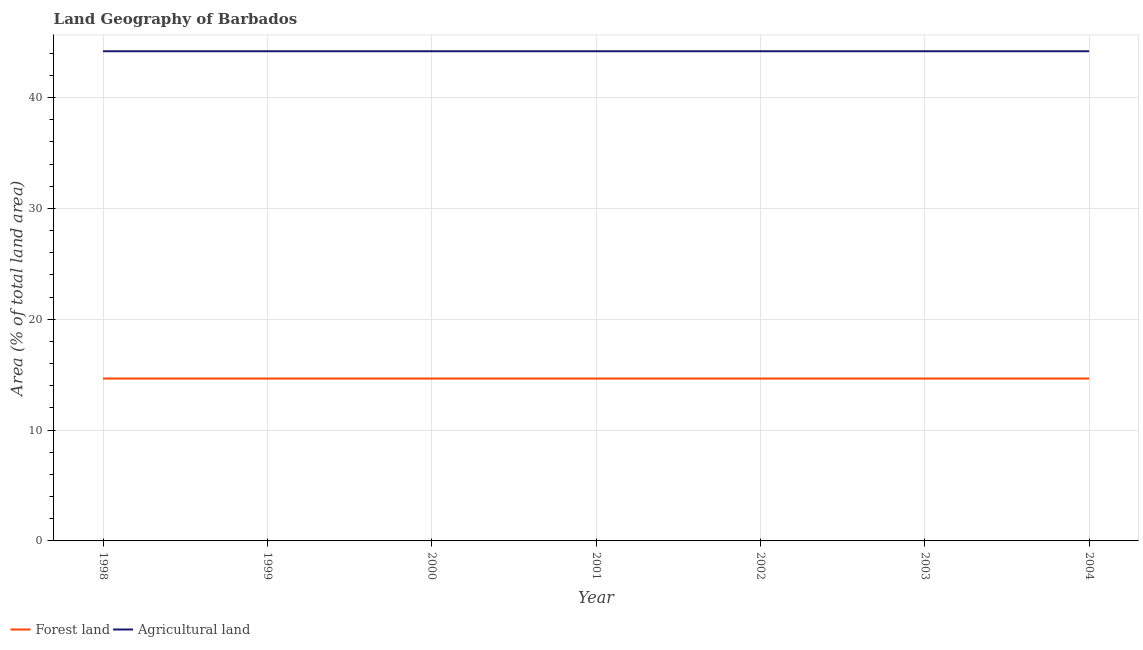How many different coloured lines are there?
Offer a very short reply. 2. Is the number of lines equal to the number of legend labels?
Your answer should be very brief. Yes. What is the percentage of land area under forests in 2003?
Offer a very short reply. 14.65. Across all years, what is the maximum percentage of land area under agriculture?
Ensure brevity in your answer.  44.19. Across all years, what is the minimum percentage of land area under forests?
Give a very brief answer. 14.65. What is the total percentage of land area under agriculture in the graph?
Provide a short and direct response. 309.3. What is the difference between the percentage of land area under agriculture in 2003 and that in 2004?
Keep it short and to the point. 0. What is the difference between the percentage of land area under forests in 2004 and the percentage of land area under agriculture in 2001?
Provide a succinct answer. -29.53. What is the average percentage of land area under forests per year?
Offer a very short reply. 14.65. In the year 2002, what is the difference between the percentage of land area under agriculture and percentage of land area under forests?
Provide a short and direct response. 29.53. Is the percentage of land area under agriculture in 2000 less than that in 2004?
Provide a succinct answer. No. Is the sum of the percentage of land area under agriculture in 2001 and 2004 greater than the maximum percentage of land area under forests across all years?
Your answer should be compact. Yes. Does the percentage of land area under agriculture monotonically increase over the years?
Your response must be concise. No. Is the percentage of land area under agriculture strictly greater than the percentage of land area under forests over the years?
Provide a succinct answer. Yes. How many lines are there?
Keep it short and to the point. 2. What is the difference between two consecutive major ticks on the Y-axis?
Provide a short and direct response. 10. Are the values on the major ticks of Y-axis written in scientific E-notation?
Provide a succinct answer. No. Does the graph contain grids?
Provide a short and direct response. Yes. Where does the legend appear in the graph?
Your answer should be very brief. Bottom left. What is the title of the graph?
Offer a very short reply. Land Geography of Barbados. Does "Male" appear as one of the legend labels in the graph?
Your response must be concise. No. What is the label or title of the Y-axis?
Ensure brevity in your answer.  Area (% of total land area). What is the Area (% of total land area) in Forest land in 1998?
Give a very brief answer. 14.65. What is the Area (% of total land area) of Agricultural land in 1998?
Keep it short and to the point. 44.19. What is the Area (% of total land area) in Forest land in 1999?
Your answer should be very brief. 14.65. What is the Area (% of total land area) of Agricultural land in 1999?
Make the answer very short. 44.19. What is the Area (% of total land area) in Forest land in 2000?
Your answer should be very brief. 14.65. What is the Area (% of total land area) of Agricultural land in 2000?
Offer a terse response. 44.19. What is the Area (% of total land area) of Forest land in 2001?
Make the answer very short. 14.65. What is the Area (% of total land area) in Agricultural land in 2001?
Keep it short and to the point. 44.19. What is the Area (% of total land area) of Forest land in 2002?
Your response must be concise. 14.65. What is the Area (% of total land area) in Agricultural land in 2002?
Your response must be concise. 44.19. What is the Area (% of total land area) in Forest land in 2003?
Provide a succinct answer. 14.65. What is the Area (% of total land area) of Agricultural land in 2003?
Your response must be concise. 44.19. What is the Area (% of total land area) in Forest land in 2004?
Your response must be concise. 14.65. What is the Area (% of total land area) in Agricultural land in 2004?
Make the answer very short. 44.19. Across all years, what is the maximum Area (% of total land area) in Forest land?
Offer a very short reply. 14.65. Across all years, what is the maximum Area (% of total land area) in Agricultural land?
Your answer should be very brief. 44.19. Across all years, what is the minimum Area (% of total land area) in Forest land?
Your response must be concise. 14.65. Across all years, what is the minimum Area (% of total land area) in Agricultural land?
Give a very brief answer. 44.19. What is the total Area (% of total land area) in Forest land in the graph?
Provide a succinct answer. 102.56. What is the total Area (% of total land area) in Agricultural land in the graph?
Provide a succinct answer. 309.3. What is the difference between the Area (% of total land area) in Forest land in 1998 and that in 1999?
Ensure brevity in your answer.  0. What is the difference between the Area (% of total land area) of Agricultural land in 1998 and that in 1999?
Keep it short and to the point. 0. What is the difference between the Area (% of total land area) of Agricultural land in 1998 and that in 2000?
Keep it short and to the point. 0. What is the difference between the Area (% of total land area) in Forest land in 1998 and that in 2003?
Offer a very short reply. 0. What is the difference between the Area (% of total land area) of Forest land in 1998 and that in 2004?
Provide a short and direct response. 0. What is the difference between the Area (% of total land area) of Forest land in 1999 and that in 2000?
Your answer should be compact. 0. What is the difference between the Area (% of total land area) in Agricultural land in 1999 and that in 2000?
Keep it short and to the point. 0. What is the difference between the Area (% of total land area) in Forest land in 1999 and that in 2003?
Give a very brief answer. 0. What is the difference between the Area (% of total land area) of Agricultural land in 1999 and that in 2003?
Your answer should be very brief. 0. What is the difference between the Area (% of total land area) of Forest land in 2000 and that in 2001?
Your answer should be compact. 0. What is the difference between the Area (% of total land area) of Agricultural land in 2000 and that in 2001?
Give a very brief answer. 0. What is the difference between the Area (% of total land area) in Forest land in 2000 and that in 2002?
Offer a terse response. 0. What is the difference between the Area (% of total land area) in Agricultural land in 2000 and that in 2004?
Provide a succinct answer. 0. What is the difference between the Area (% of total land area) in Forest land in 2001 and that in 2003?
Offer a very short reply. 0. What is the difference between the Area (% of total land area) of Agricultural land in 2001 and that in 2003?
Make the answer very short. 0. What is the difference between the Area (% of total land area) in Forest land in 2001 and that in 2004?
Offer a very short reply. 0. What is the difference between the Area (% of total land area) in Forest land in 2002 and that in 2003?
Keep it short and to the point. 0. What is the difference between the Area (% of total land area) of Agricultural land in 2002 and that in 2003?
Ensure brevity in your answer.  0. What is the difference between the Area (% of total land area) of Forest land in 2002 and that in 2004?
Provide a short and direct response. 0. What is the difference between the Area (% of total land area) of Agricultural land in 2002 and that in 2004?
Offer a very short reply. 0. What is the difference between the Area (% of total land area) in Forest land in 2003 and that in 2004?
Make the answer very short. 0. What is the difference between the Area (% of total land area) of Agricultural land in 2003 and that in 2004?
Offer a terse response. 0. What is the difference between the Area (% of total land area) in Forest land in 1998 and the Area (% of total land area) in Agricultural land in 1999?
Provide a succinct answer. -29.53. What is the difference between the Area (% of total land area) of Forest land in 1998 and the Area (% of total land area) of Agricultural land in 2000?
Offer a very short reply. -29.53. What is the difference between the Area (% of total land area) of Forest land in 1998 and the Area (% of total land area) of Agricultural land in 2001?
Ensure brevity in your answer.  -29.53. What is the difference between the Area (% of total land area) in Forest land in 1998 and the Area (% of total land area) in Agricultural land in 2002?
Your response must be concise. -29.53. What is the difference between the Area (% of total land area) in Forest land in 1998 and the Area (% of total land area) in Agricultural land in 2003?
Give a very brief answer. -29.53. What is the difference between the Area (% of total land area) of Forest land in 1998 and the Area (% of total land area) of Agricultural land in 2004?
Provide a succinct answer. -29.53. What is the difference between the Area (% of total land area) in Forest land in 1999 and the Area (% of total land area) in Agricultural land in 2000?
Provide a short and direct response. -29.53. What is the difference between the Area (% of total land area) in Forest land in 1999 and the Area (% of total land area) in Agricultural land in 2001?
Your response must be concise. -29.53. What is the difference between the Area (% of total land area) in Forest land in 1999 and the Area (% of total land area) in Agricultural land in 2002?
Your answer should be very brief. -29.53. What is the difference between the Area (% of total land area) in Forest land in 1999 and the Area (% of total land area) in Agricultural land in 2003?
Your response must be concise. -29.53. What is the difference between the Area (% of total land area) of Forest land in 1999 and the Area (% of total land area) of Agricultural land in 2004?
Make the answer very short. -29.53. What is the difference between the Area (% of total land area) in Forest land in 2000 and the Area (% of total land area) in Agricultural land in 2001?
Your response must be concise. -29.53. What is the difference between the Area (% of total land area) of Forest land in 2000 and the Area (% of total land area) of Agricultural land in 2002?
Ensure brevity in your answer.  -29.53. What is the difference between the Area (% of total land area) of Forest land in 2000 and the Area (% of total land area) of Agricultural land in 2003?
Your response must be concise. -29.53. What is the difference between the Area (% of total land area) of Forest land in 2000 and the Area (% of total land area) of Agricultural land in 2004?
Offer a terse response. -29.53. What is the difference between the Area (% of total land area) in Forest land in 2001 and the Area (% of total land area) in Agricultural land in 2002?
Provide a succinct answer. -29.53. What is the difference between the Area (% of total land area) in Forest land in 2001 and the Area (% of total land area) in Agricultural land in 2003?
Provide a succinct answer. -29.53. What is the difference between the Area (% of total land area) of Forest land in 2001 and the Area (% of total land area) of Agricultural land in 2004?
Your answer should be very brief. -29.53. What is the difference between the Area (% of total land area) of Forest land in 2002 and the Area (% of total land area) of Agricultural land in 2003?
Give a very brief answer. -29.53. What is the difference between the Area (% of total land area) in Forest land in 2002 and the Area (% of total land area) in Agricultural land in 2004?
Your response must be concise. -29.53. What is the difference between the Area (% of total land area) in Forest land in 2003 and the Area (% of total land area) in Agricultural land in 2004?
Offer a terse response. -29.53. What is the average Area (% of total land area) in Forest land per year?
Your response must be concise. 14.65. What is the average Area (% of total land area) in Agricultural land per year?
Make the answer very short. 44.19. In the year 1998, what is the difference between the Area (% of total land area) of Forest land and Area (% of total land area) of Agricultural land?
Provide a short and direct response. -29.53. In the year 1999, what is the difference between the Area (% of total land area) in Forest land and Area (% of total land area) in Agricultural land?
Ensure brevity in your answer.  -29.53. In the year 2000, what is the difference between the Area (% of total land area) in Forest land and Area (% of total land area) in Agricultural land?
Your answer should be very brief. -29.53. In the year 2001, what is the difference between the Area (% of total land area) in Forest land and Area (% of total land area) in Agricultural land?
Your response must be concise. -29.53. In the year 2002, what is the difference between the Area (% of total land area) in Forest land and Area (% of total land area) in Agricultural land?
Make the answer very short. -29.53. In the year 2003, what is the difference between the Area (% of total land area) of Forest land and Area (% of total land area) of Agricultural land?
Provide a succinct answer. -29.53. In the year 2004, what is the difference between the Area (% of total land area) of Forest land and Area (% of total land area) of Agricultural land?
Give a very brief answer. -29.53. What is the ratio of the Area (% of total land area) of Agricultural land in 1998 to that in 1999?
Provide a short and direct response. 1. What is the ratio of the Area (% of total land area) in Agricultural land in 1998 to that in 2000?
Your answer should be compact. 1. What is the ratio of the Area (% of total land area) of Forest land in 1998 to that in 2001?
Ensure brevity in your answer.  1. What is the ratio of the Area (% of total land area) in Forest land in 1998 to that in 2003?
Offer a terse response. 1. What is the ratio of the Area (% of total land area) of Agricultural land in 1998 to that in 2003?
Ensure brevity in your answer.  1. What is the ratio of the Area (% of total land area) in Agricultural land in 1998 to that in 2004?
Provide a short and direct response. 1. What is the ratio of the Area (% of total land area) of Agricultural land in 1999 to that in 2001?
Keep it short and to the point. 1. What is the ratio of the Area (% of total land area) in Agricultural land in 1999 to that in 2002?
Give a very brief answer. 1. What is the ratio of the Area (% of total land area) of Forest land in 1999 to that in 2003?
Make the answer very short. 1. What is the ratio of the Area (% of total land area) of Agricultural land in 1999 to that in 2003?
Give a very brief answer. 1. What is the ratio of the Area (% of total land area) of Forest land in 1999 to that in 2004?
Keep it short and to the point. 1. What is the ratio of the Area (% of total land area) in Agricultural land in 1999 to that in 2004?
Ensure brevity in your answer.  1. What is the ratio of the Area (% of total land area) of Forest land in 2000 to that in 2002?
Your answer should be compact. 1. What is the ratio of the Area (% of total land area) in Agricultural land in 2000 to that in 2002?
Keep it short and to the point. 1. What is the ratio of the Area (% of total land area) in Forest land in 2000 to that in 2003?
Ensure brevity in your answer.  1. What is the ratio of the Area (% of total land area) of Agricultural land in 2000 to that in 2003?
Provide a succinct answer. 1. What is the ratio of the Area (% of total land area) of Forest land in 2001 to that in 2002?
Your answer should be very brief. 1. What is the ratio of the Area (% of total land area) of Agricultural land in 2002 to that in 2003?
Your answer should be very brief. 1. What is the ratio of the Area (% of total land area) in Forest land in 2002 to that in 2004?
Make the answer very short. 1. What is the ratio of the Area (% of total land area) of Agricultural land in 2002 to that in 2004?
Make the answer very short. 1. What is the ratio of the Area (% of total land area) of Forest land in 2003 to that in 2004?
Provide a succinct answer. 1. What is the difference between the highest and the lowest Area (% of total land area) in Agricultural land?
Your answer should be compact. 0. 